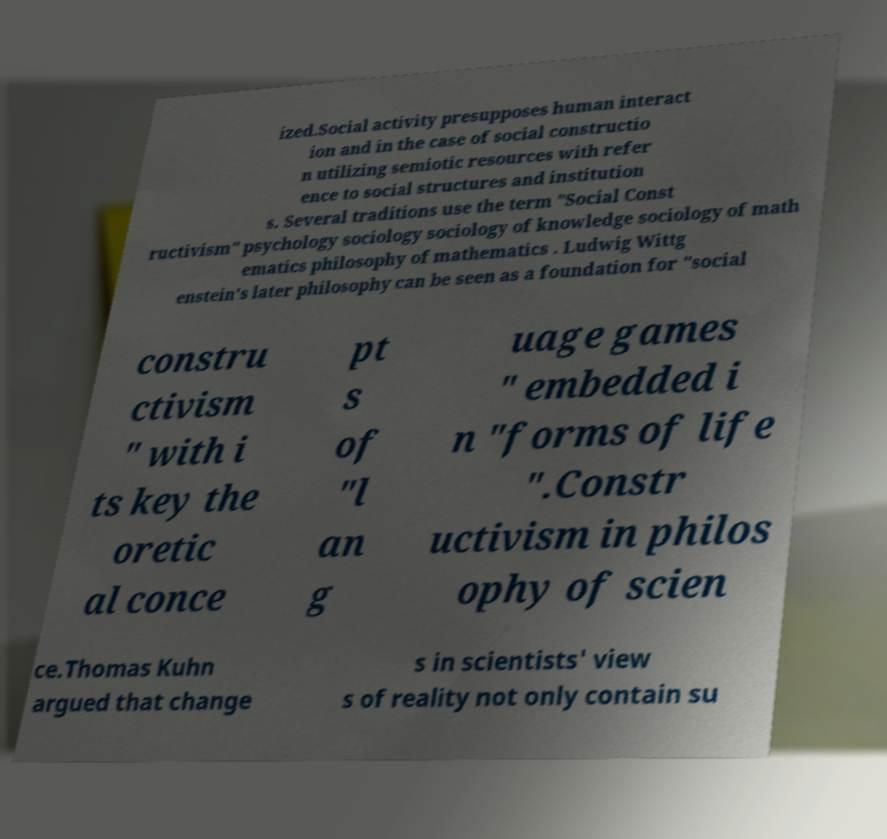Could you assist in decoding the text presented in this image and type it out clearly? ized.Social activity presupposes human interact ion and in the case of social constructio n utilizing semiotic resources with refer ence to social structures and institution s. Several traditions use the term "Social Const ructivism" psychology sociology sociology of knowledge sociology of math ematics philosophy of mathematics . Ludwig Wittg enstein's later philosophy can be seen as a foundation for "social constru ctivism " with i ts key the oretic al conce pt s of "l an g uage games " embedded i n "forms of life ".Constr uctivism in philos ophy of scien ce.Thomas Kuhn argued that change s in scientists' view s of reality not only contain su 